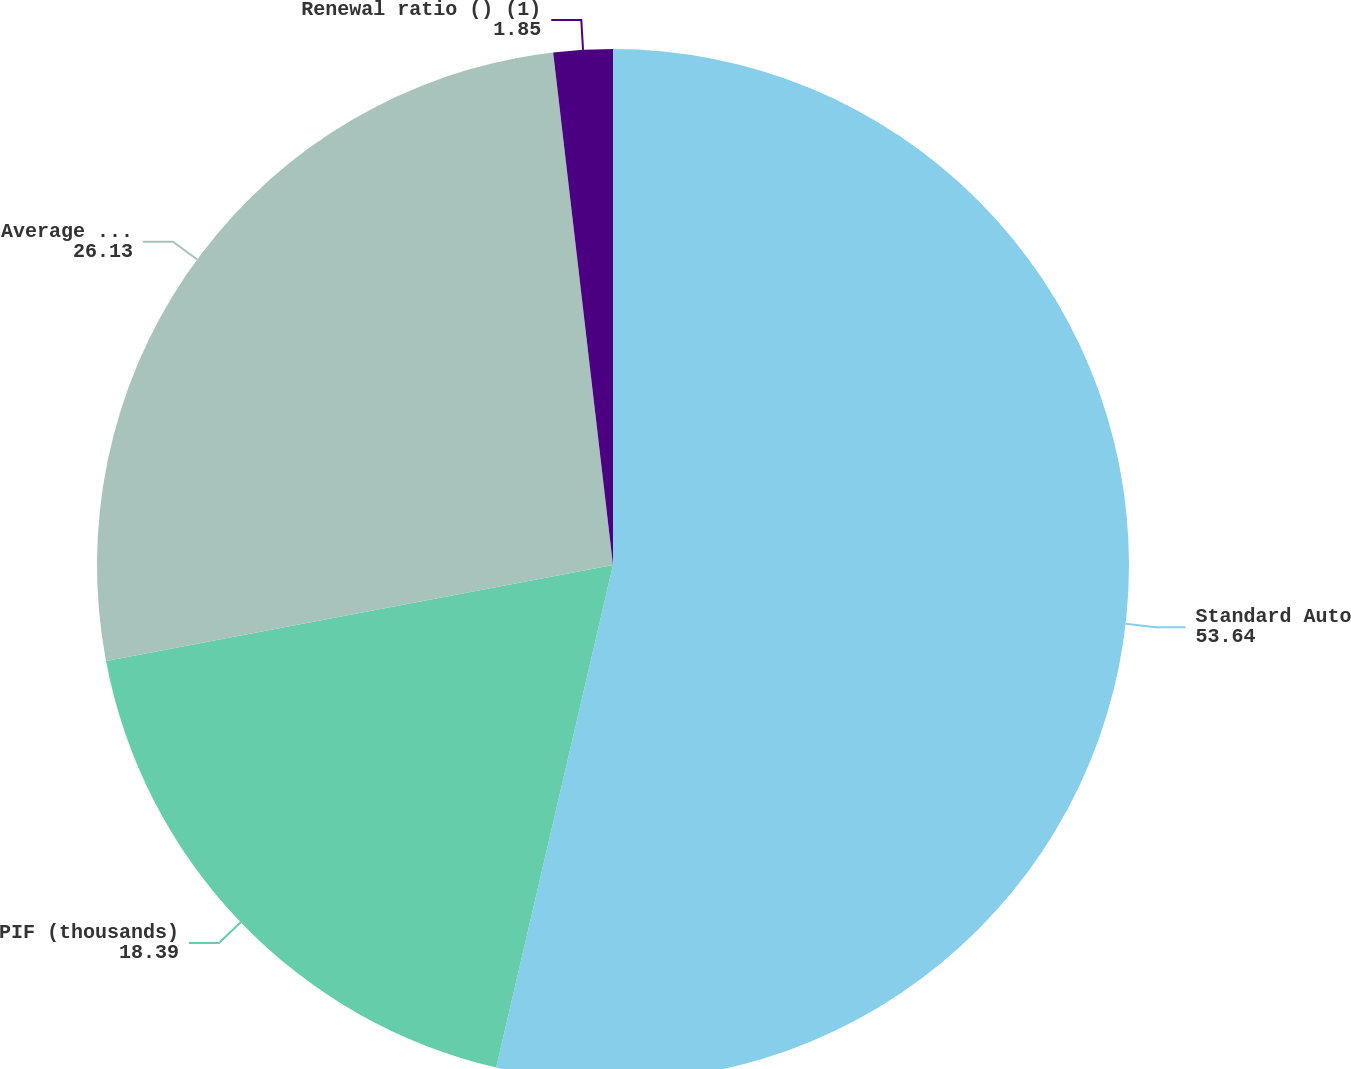Convert chart. <chart><loc_0><loc_0><loc_500><loc_500><pie_chart><fcel>Standard Auto<fcel>PIF (thousands)<fcel>Average premium-gross written<fcel>Renewal ratio () (1)<nl><fcel>53.64%<fcel>18.39%<fcel>26.13%<fcel>1.85%<nl></chart> 